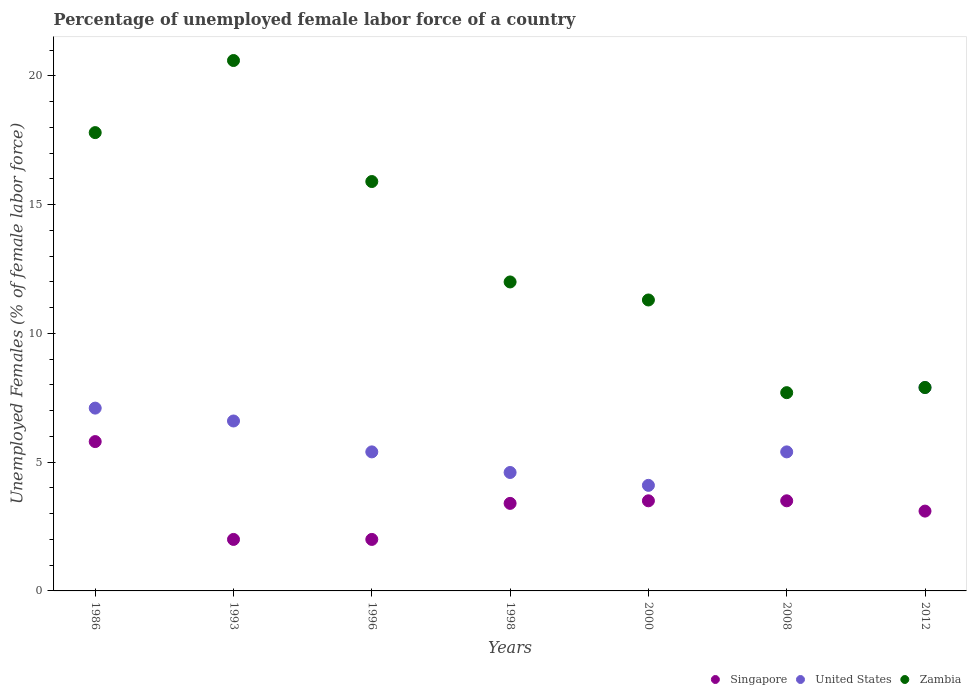How many different coloured dotlines are there?
Offer a very short reply. 3. What is the percentage of unemployed female labor force in Singapore in 1996?
Offer a terse response. 2. Across all years, what is the maximum percentage of unemployed female labor force in Singapore?
Ensure brevity in your answer.  5.8. Across all years, what is the minimum percentage of unemployed female labor force in Singapore?
Offer a terse response. 2. In which year was the percentage of unemployed female labor force in Zambia maximum?
Give a very brief answer. 1993. What is the total percentage of unemployed female labor force in Zambia in the graph?
Your response must be concise. 93.2. What is the difference between the percentage of unemployed female labor force in United States in 2000 and that in 2008?
Provide a succinct answer. -1.3. What is the difference between the percentage of unemployed female labor force in United States in 1993 and the percentage of unemployed female labor force in Singapore in 1986?
Your answer should be very brief. 0.8. What is the average percentage of unemployed female labor force in Zambia per year?
Your answer should be very brief. 13.31. In the year 1998, what is the difference between the percentage of unemployed female labor force in Singapore and percentage of unemployed female labor force in United States?
Provide a succinct answer. -1.2. What is the ratio of the percentage of unemployed female labor force in United States in 2008 to that in 2012?
Offer a terse response. 0.68. Is the percentage of unemployed female labor force in United States in 1986 less than that in 1993?
Your answer should be compact. No. What is the difference between the highest and the second highest percentage of unemployed female labor force in Zambia?
Your answer should be very brief. 2.8. What is the difference between the highest and the lowest percentage of unemployed female labor force in United States?
Keep it short and to the point. 3.8. Is the sum of the percentage of unemployed female labor force in Zambia in 1993 and 2008 greater than the maximum percentage of unemployed female labor force in United States across all years?
Your answer should be very brief. Yes. Is it the case that in every year, the sum of the percentage of unemployed female labor force in United States and percentage of unemployed female labor force in Zambia  is greater than the percentage of unemployed female labor force in Singapore?
Make the answer very short. Yes. Is the percentage of unemployed female labor force in United States strictly greater than the percentage of unemployed female labor force in Singapore over the years?
Provide a short and direct response. Yes. Is the percentage of unemployed female labor force in Singapore strictly less than the percentage of unemployed female labor force in Zambia over the years?
Offer a terse response. Yes. How many years are there in the graph?
Ensure brevity in your answer.  7. Are the values on the major ticks of Y-axis written in scientific E-notation?
Provide a short and direct response. No. How are the legend labels stacked?
Ensure brevity in your answer.  Horizontal. What is the title of the graph?
Your response must be concise. Percentage of unemployed female labor force of a country. What is the label or title of the X-axis?
Provide a succinct answer. Years. What is the label or title of the Y-axis?
Make the answer very short. Unemployed Females (% of female labor force). What is the Unemployed Females (% of female labor force) of Singapore in 1986?
Your response must be concise. 5.8. What is the Unemployed Females (% of female labor force) in United States in 1986?
Ensure brevity in your answer.  7.1. What is the Unemployed Females (% of female labor force) of Zambia in 1986?
Make the answer very short. 17.8. What is the Unemployed Females (% of female labor force) in United States in 1993?
Ensure brevity in your answer.  6.6. What is the Unemployed Females (% of female labor force) in Zambia in 1993?
Give a very brief answer. 20.6. What is the Unemployed Females (% of female labor force) of Singapore in 1996?
Make the answer very short. 2. What is the Unemployed Females (% of female labor force) in United States in 1996?
Give a very brief answer. 5.4. What is the Unemployed Females (% of female labor force) in Zambia in 1996?
Offer a terse response. 15.9. What is the Unemployed Females (% of female labor force) of Singapore in 1998?
Provide a succinct answer. 3.4. What is the Unemployed Females (% of female labor force) of United States in 1998?
Make the answer very short. 4.6. What is the Unemployed Females (% of female labor force) of Zambia in 1998?
Your answer should be compact. 12. What is the Unemployed Females (% of female labor force) in United States in 2000?
Keep it short and to the point. 4.1. What is the Unemployed Females (% of female labor force) of Zambia in 2000?
Offer a very short reply. 11.3. What is the Unemployed Females (% of female labor force) of Singapore in 2008?
Your answer should be very brief. 3.5. What is the Unemployed Females (% of female labor force) in United States in 2008?
Offer a very short reply. 5.4. What is the Unemployed Females (% of female labor force) of Zambia in 2008?
Offer a terse response. 7.7. What is the Unemployed Females (% of female labor force) of Singapore in 2012?
Provide a succinct answer. 3.1. What is the Unemployed Females (% of female labor force) of United States in 2012?
Offer a terse response. 7.9. What is the Unemployed Females (% of female labor force) in Zambia in 2012?
Give a very brief answer. 7.9. Across all years, what is the maximum Unemployed Females (% of female labor force) in Singapore?
Your answer should be very brief. 5.8. Across all years, what is the maximum Unemployed Females (% of female labor force) in United States?
Your response must be concise. 7.9. Across all years, what is the maximum Unemployed Females (% of female labor force) in Zambia?
Your response must be concise. 20.6. Across all years, what is the minimum Unemployed Females (% of female labor force) in Singapore?
Ensure brevity in your answer.  2. Across all years, what is the minimum Unemployed Females (% of female labor force) of United States?
Your response must be concise. 4.1. Across all years, what is the minimum Unemployed Females (% of female labor force) in Zambia?
Your answer should be very brief. 7.7. What is the total Unemployed Females (% of female labor force) of Singapore in the graph?
Offer a terse response. 23.3. What is the total Unemployed Females (% of female labor force) of United States in the graph?
Your answer should be very brief. 41.1. What is the total Unemployed Females (% of female labor force) in Zambia in the graph?
Ensure brevity in your answer.  93.2. What is the difference between the Unemployed Females (% of female labor force) in Singapore in 1986 and that in 1993?
Provide a short and direct response. 3.8. What is the difference between the Unemployed Females (% of female labor force) in Zambia in 1986 and that in 1993?
Provide a succinct answer. -2.8. What is the difference between the Unemployed Females (% of female labor force) of United States in 1986 and that in 1998?
Your answer should be compact. 2.5. What is the difference between the Unemployed Females (% of female labor force) of Zambia in 1986 and that in 1998?
Offer a terse response. 5.8. What is the difference between the Unemployed Females (% of female labor force) in Singapore in 1986 and that in 2000?
Offer a very short reply. 2.3. What is the difference between the Unemployed Females (% of female labor force) of United States in 1986 and that in 2000?
Offer a terse response. 3. What is the difference between the Unemployed Females (% of female labor force) in Zambia in 1986 and that in 2008?
Offer a very short reply. 10.1. What is the difference between the Unemployed Females (% of female labor force) of Singapore in 1986 and that in 2012?
Your response must be concise. 2.7. What is the difference between the Unemployed Females (% of female labor force) of Zambia in 1993 and that in 1996?
Provide a short and direct response. 4.7. What is the difference between the Unemployed Females (% of female labor force) in Singapore in 1993 and that in 2000?
Ensure brevity in your answer.  -1.5. What is the difference between the Unemployed Females (% of female labor force) in United States in 1993 and that in 2000?
Your answer should be compact. 2.5. What is the difference between the Unemployed Females (% of female labor force) of Singapore in 1993 and that in 2008?
Offer a very short reply. -1.5. What is the difference between the Unemployed Females (% of female labor force) of United States in 1993 and that in 2008?
Make the answer very short. 1.2. What is the difference between the Unemployed Females (% of female labor force) in United States in 1993 and that in 2012?
Your response must be concise. -1.3. What is the difference between the Unemployed Females (% of female labor force) of Zambia in 1993 and that in 2012?
Make the answer very short. 12.7. What is the difference between the Unemployed Females (% of female labor force) of Singapore in 1996 and that in 2000?
Offer a very short reply. -1.5. What is the difference between the Unemployed Females (% of female labor force) in United States in 1996 and that in 2000?
Make the answer very short. 1.3. What is the difference between the Unemployed Females (% of female labor force) in Singapore in 1996 and that in 2008?
Offer a very short reply. -1.5. What is the difference between the Unemployed Females (% of female labor force) of United States in 1996 and that in 2008?
Your answer should be compact. 0. What is the difference between the Unemployed Females (% of female labor force) of Zambia in 1996 and that in 2008?
Provide a short and direct response. 8.2. What is the difference between the Unemployed Females (% of female labor force) of United States in 1996 and that in 2012?
Provide a short and direct response. -2.5. What is the difference between the Unemployed Females (% of female labor force) in United States in 1998 and that in 2000?
Offer a terse response. 0.5. What is the difference between the Unemployed Females (% of female labor force) in Zambia in 1998 and that in 2008?
Give a very brief answer. 4.3. What is the difference between the Unemployed Females (% of female labor force) in United States in 1998 and that in 2012?
Make the answer very short. -3.3. What is the difference between the Unemployed Females (% of female labor force) of Zambia in 1998 and that in 2012?
Provide a short and direct response. 4.1. What is the difference between the Unemployed Females (% of female labor force) of Singapore in 2000 and that in 2008?
Keep it short and to the point. 0. What is the difference between the Unemployed Females (% of female labor force) of Singapore in 2000 and that in 2012?
Your response must be concise. 0.4. What is the difference between the Unemployed Females (% of female labor force) in United States in 2000 and that in 2012?
Keep it short and to the point. -3.8. What is the difference between the Unemployed Females (% of female labor force) in United States in 2008 and that in 2012?
Keep it short and to the point. -2.5. What is the difference between the Unemployed Females (% of female labor force) of Zambia in 2008 and that in 2012?
Make the answer very short. -0.2. What is the difference between the Unemployed Females (% of female labor force) of Singapore in 1986 and the Unemployed Females (% of female labor force) of United States in 1993?
Your response must be concise. -0.8. What is the difference between the Unemployed Females (% of female labor force) of Singapore in 1986 and the Unemployed Females (% of female labor force) of Zambia in 1993?
Make the answer very short. -14.8. What is the difference between the Unemployed Females (% of female labor force) of Singapore in 1986 and the Unemployed Females (% of female labor force) of Zambia in 1996?
Your response must be concise. -10.1. What is the difference between the Unemployed Females (% of female labor force) in United States in 1986 and the Unemployed Females (% of female labor force) in Zambia in 1996?
Provide a short and direct response. -8.8. What is the difference between the Unemployed Females (% of female labor force) of Singapore in 1986 and the Unemployed Females (% of female labor force) of United States in 1998?
Your answer should be very brief. 1.2. What is the difference between the Unemployed Females (% of female labor force) in Singapore in 1986 and the Unemployed Females (% of female labor force) in United States in 2008?
Provide a succinct answer. 0.4. What is the difference between the Unemployed Females (% of female labor force) in Singapore in 1986 and the Unemployed Females (% of female labor force) in Zambia in 2008?
Your response must be concise. -1.9. What is the difference between the Unemployed Females (% of female labor force) in United States in 1986 and the Unemployed Females (% of female labor force) in Zambia in 2008?
Give a very brief answer. -0.6. What is the difference between the Unemployed Females (% of female labor force) in Singapore in 1986 and the Unemployed Females (% of female labor force) in Zambia in 2012?
Your answer should be very brief. -2.1. What is the difference between the Unemployed Females (% of female labor force) in United States in 1986 and the Unemployed Females (% of female labor force) in Zambia in 2012?
Make the answer very short. -0.8. What is the difference between the Unemployed Females (% of female labor force) of Singapore in 1993 and the Unemployed Females (% of female labor force) of United States in 1996?
Offer a terse response. -3.4. What is the difference between the Unemployed Females (% of female labor force) of Singapore in 1993 and the Unemployed Females (% of female labor force) of Zambia in 1996?
Your response must be concise. -13.9. What is the difference between the Unemployed Females (% of female labor force) in United States in 1993 and the Unemployed Females (% of female labor force) in Zambia in 1996?
Make the answer very short. -9.3. What is the difference between the Unemployed Females (% of female labor force) in United States in 1993 and the Unemployed Females (% of female labor force) in Zambia in 1998?
Offer a very short reply. -5.4. What is the difference between the Unemployed Females (% of female labor force) in Singapore in 1993 and the Unemployed Females (% of female labor force) in United States in 2008?
Provide a short and direct response. -3.4. What is the difference between the Unemployed Females (% of female labor force) in Singapore in 1993 and the Unemployed Females (% of female labor force) in Zambia in 2008?
Keep it short and to the point. -5.7. What is the difference between the Unemployed Females (% of female labor force) in Singapore in 1993 and the Unemployed Females (% of female labor force) in Zambia in 2012?
Make the answer very short. -5.9. What is the difference between the Unemployed Females (% of female labor force) in Singapore in 1996 and the Unemployed Females (% of female labor force) in United States in 1998?
Offer a terse response. -2.6. What is the difference between the Unemployed Females (% of female labor force) of United States in 1996 and the Unemployed Females (% of female labor force) of Zambia in 1998?
Offer a terse response. -6.6. What is the difference between the Unemployed Females (% of female labor force) of Singapore in 1996 and the Unemployed Females (% of female labor force) of United States in 2000?
Ensure brevity in your answer.  -2.1. What is the difference between the Unemployed Females (% of female labor force) in United States in 1996 and the Unemployed Females (% of female labor force) in Zambia in 2008?
Keep it short and to the point. -2.3. What is the difference between the Unemployed Females (% of female labor force) in United States in 1996 and the Unemployed Females (% of female labor force) in Zambia in 2012?
Keep it short and to the point. -2.5. What is the difference between the Unemployed Females (% of female labor force) of Singapore in 1998 and the Unemployed Females (% of female labor force) of Zambia in 2000?
Ensure brevity in your answer.  -7.9. What is the difference between the Unemployed Females (% of female labor force) of United States in 1998 and the Unemployed Females (% of female labor force) of Zambia in 2008?
Give a very brief answer. -3.1. What is the difference between the Unemployed Females (% of female labor force) in Singapore in 1998 and the Unemployed Females (% of female labor force) in United States in 2012?
Provide a short and direct response. -4.5. What is the difference between the Unemployed Females (% of female labor force) of Singapore in 2000 and the Unemployed Females (% of female labor force) of United States in 2008?
Provide a succinct answer. -1.9. What is the difference between the Unemployed Females (% of female labor force) of Singapore in 2000 and the Unemployed Females (% of female labor force) of Zambia in 2008?
Your response must be concise. -4.2. What is the difference between the Unemployed Females (% of female labor force) of Singapore in 2000 and the Unemployed Females (% of female labor force) of United States in 2012?
Ensure brevity in your answer.  -4.4. What is the difference between the Unemployed Females (% of female labor force) in Singapore in 2000 and the Unemployed Females (% of female labor force) in Zambia in 2012?
Provide a short and direct response. -4.4. What is the average Unemployed Females (% of female labor force) in Singapore per year?
Offer a very short reply. 3.33. What is the average Unemployed Females (% of female labor force) of United States per year?
Provide a succinct answer. 5.87. What is the average Unemployed Females (% of female labor force) in Zambia per year?
Give a very brief answer. 13.31. In the year 1986, what is the difference between the Unemployed Females (% of female labor force) in Singapore and Unemployed Females (% of female labor force) in United States?
Your answer should be compact. -1.3. In the year 1986, what is the difference between the Unemployed Females (% of female labor force) of Singapore and Unemployed Females (% of female labor force) of Zambia?
Offer a terse response. -12. In the year 1993, what is the difference between the Unemployed Females (% of female labor force) of Singapore and Unemployed Females (% of female labor force) of United States?
Ensure brevity in your answer.  -4.6. In the year 1993, what is the difference between the Unemployed Females (% of female labor force) of Singapore and Unemployed Females (% of female labor force) of Zambia?
Offer a terse response. -18.6. In the year 1993, what is the difference between the Unemployed Females (% of female labor force) of United States and Unemployed Females (% of female labor force) of Zambia?
Make the answer very short. -14. In the year 1996, what is the difference between the Unemployed Females (% of female labor force) in Singapore and Unemployed Females (% of female labor force) in United States?
Your response must be concise. -3.4. In the year 1996, what is the difference between the Unemployed Females (% of female labor force) in Singapore and Unemployed Females (% of female labor force) in Zambia?
Offer a terse response. -13.9. In the year 1996, what is the difference between the Unemployed Females (% of female labor force) in United States and Unemployed Females (% of female labor force) in Zambia?
Your answer should be compact. -10.5. In the year 1998, what is the difference between the Unemployed Females (% of female labor force) of Singapore and Unemployed Females (% of female labor force) of Zambia?
Your response must be concise. -8.6. In the year 2000, what is the difference between the Unemployed Females (% of female labor force) in Singapore and Unemployed Females (% of female labor force) in United States?
Your response must be concise. -0.6. In the year 2008, what is the difference between the Unemployed Females (% of female labor force) of Singapore and Unemployed Females (% of female labor force) of United States?
Offer a very short reply. -1.9. In the year 2012, what is the difference between the Unemployed Females (% of female labor force) of Singapore and Unemployed Females (% of female labor force) of United States?
Keep it short and to the point. -4.8. In the year 2012, what is the difference between the Unemployed Females (% of female labor force) in United States and Unemployed Females (% of female labor force) in Zambia?
Provide a succinct answer. 0. What is the ratio of the Unemployed Females (% of female labor force) in United States in 1986 to that in 1993?
Offer a very short reply. 1.08. What is the ratio of the Unemployed Females (% of female labor force) in Zambia in 1986 to that in 1993?
Ensure brevity in your answer.  0.86. What is the ratio of the Unemployed Females (% of female labor force) of United States in 1986 to that in 1996?
Provide a succinct answer. 1.31. What is the ratio of the Unemployed Females (% of female labor force) of Zambia in 1986 to that in 1996?
Offer a very short reply. 1.12. What is the ratio of the Unemployed Females (% of female labor force) in Singapore in 1986 to that in 1998?
Make the answer very short. 1.71. What is the ratio of the Unemployed Females (% of female labor force) in United States in 1986 to that in 1998?
Give a very brief answer. 1.54. What is the ratio of the Unemployed Females (% of female labor force) in Zambia in 1986 to that in 1998?
Your response must be concise. 1.48. What is the ratio of the Unemployed Females (% of female labor force) in Singapore in 1986 to that in 2000?
Provide a succinct answer. 1.66. What is the ratio of the Unemployed Females (% of female labor force) of United States in 1986 to that in 2000?
Your response must be concise. 1.73. What is the ratio of the Unemployed Females (% of female labor force) of Zambia in 1986 to that in 2000?
Your response must be concise. 1.58. What is the ratio of the Unemployed Females (% of female labor force) of Singapore in 1986 to that in 2008?
Offer a terse response. 1.66. What is the ratio of the Unemployed Females (% of female labor force) in United States in 1986 to that in 2008?
Your answer should be compact. 1.31. What is the ratio of the Unemployed Females (% of female labor force) of Zambia in 1986 to that in 2008?
Offer a terse response. 2.31. What is the ratio of the Unemployed Females (% of female labor force) of Singapore in 1986 to that in 2012?
Your response must be concise. 1.87. What is the ratio of the Unemployed Females (% of female labor force) in United States in 1986 to that in 2012?
Provide a short and direct response. 0.9. What is the ratio of the Unemployed Females (% of female labor force) of Zambia in 1986 to that in 2012?
Your answer should be very brief. 2.25. What is the ratio of the Unemployed Females (% of female labor force) of Singapore in 1993 to that in 1996?
Your answer should be compact. 1. What is the ratio of the Unemployed Females (% of female labor force) in United States in 1993 to that in 1996?
Ensure brevity in your answer.  1.22. What is the ratio of the Unemployed Females (% of female labor force) in Zambia in 1993 to that in 1996?
Keep it short and to the point. 1.3. What is the ratio of the Unemployed Females (% of female labor force) in Singapore in 1993 to that in 1998?
Provide a succinct answer. 0.59. What is the ratio of the Unemployed Females (% of female labor force) of United States in 1993 to that in 1998?
Your answer should be compact. 1.43. What is the ratio of the Unemployed Females (% of female labor force) of Zambia in 1993 to that in 1998?
Your response must be concise. 1.72. What is the ratio of the Unemployed Females (% of female labor force) in United States in 1993 to that in 2000?
Provide a succinct answer. 1.61. What is the ratio of the Unemployed Females (% of female labor force) in Zambia in 1993 to that in 2000?
Ensure brevity in your answer.  1.82. What is the ratio of the Unemployed Females (% of female labor force) of Singapore in 1993 to that in 2008?
Ensure brevity in your answer.  0.57. What is the ratio of the Unemployed Females (% of female labor force) of United States in 1993 to that in 2008?
Your response must be concise. 1.22. What is the ratio of the Unemployed Females (% of female labor force) in Zambia in 1993 to that in 2008?
Your answer should be compact. 2.68. What is the ratio of the Unemployed Females (% of female labor force) of Singapore in 1993 to that in 2012?
Your response must be concise. 0.65. What is the ratio of the Unemployed Females (% of female labor force) of United States in 1993 to that in 2012?
Provide a succinct answer. 0.84. What is the ratio of the Unemployed Females (% of female labor force) in Zambia in 1993 to that in 2012?
Your response must be concise. 2.61. What is the ratio of the Unemployed Females (% of female labor force) of Singapore in 1996 to that in 1998?
Offer a terse response. 0.59. What is the ratio of the Unemployed Females (% of female labor force) of United States in 1996 to that in 1998?
Provide a short and direct response. 1.17. What is the ratio of the Unemployed Females (% of female labor force) in Zambia in 1996 to that in 1998?
Your answer should be compact. 1.32. What is the ratio of the Unemployed Females (% of female labor force) in Singapore in 1996 to that in 2000?
Provide a short and direct response. 0.57. What is the ratio of the Unemployed Females (% of female labor force) of United States in 1996 to that in 2000?
Provide a succinct answer. 1.32. What is the ratio of the Unemployed Females (% of female labor force) in Zambia in 1996 to that in 2000?
Give a very brief answer. 1.41. What is the ratio of the Unemployed Females (% of female labor force) of Singapore in 1996 to that in 2008?
Your answer should be compact. 0.57. What is the ratio of the Unemployed Females (% of female labor force) of Zambia in 1996 to that in 2008?
Provide a succinct answer. 2.06. What is the ratio of the Unemployed Females (% of female labor force) of Singapore in 1996 to that in 2012?
Make the answer very short. 0.65. What is the ratio of the Unemployed Females (% of female labor force) of United States in 1996 to that in 2012?
Keep it short and to the point. 0.68. What is the ratio of the Unemployed Females (% of female labor force) in Zambia in 1996 to that in 2012?
Give a very brief answer. 2.01. What is the ratio of the Unemployed Females (% of female labor force) of Singapore in 1998 to that in 2000?
Offer a terse response. 0.97. What is the ratio of the Unemployed Females (% of female labor force) of United States in 1998 to that in 2000?
Offer a terse response. 1.12. What is the ratio of the Unemployed Females (% of female labor force) of Zambia in 1998 to that in 2000?
Give a very brief answer. 1.06. What is the ratio of the Unemployed Females (% of female labor force) of Singapore in 1998 to that in 2008?
Your answer should be very brief. 0.97. What is the ratio of the Unemployed Females (% of female labor force) of United States in 1998 to that in 2008?
Provide a succinct answer. 0.85. What is the ratio of the Unemployed Females (% of female labor force) of Zambia in 1998 to that in 2008?
Make the answer very short. 1.56. What is the ratio of the Unemployed Females (% of female labor force) in Singapore in 1998 to that in 2012?
Your answer should be very brief. 1.1. What is the ratio of the Unemployed Females (% of female labor force) in United States in 1998 to that in 2012?
Offer a very short reply. 0.58. What is the ratio of the Unemployed Females (% of female labor force) in Zambia in 1998 to that in 2012?
Provide a succinct answer. 1.52. What is the ratio of the Unemployed Females (% of female labor force) of Singapore in 2000 to that in 2008?
Your answer should be compact. 1. What is the ratio of the Unemployed Females (% of female labor force) of United States in 2000 to that in 2008?
Make the answer very short. 0.76. What is the ratio of the Unemployed Females (% of female labor force) of Zambia in 2000 to that in 2008?
Offer a very short reply. 1.47. What is the ratio of the Unemployed Females (% of female labor force) of Singapore in 2000 to that in 2012?
Your answer should be very brief. 1.13. What is the ratio of the Unemployed Females (% of female labor force) of United States in 2000 to that in 2012?
Keep it short and to the point. 0.52. What is the ratio of the Unemployed Females (% of female labor force) in Zambia in 2000 to that in 2012?
Your answer should be very brief. 1.43. What is the ratio of the Unemployed Females (% of female labor force) of Singapore in 2008 to that in 2012?
Keep it short and to the point. 1.13. What is the ratio of the Unemployed Females (% of female labor force) of United States in 2008 to that in 2012?
Your answer should be compact. 0.68. What is the ratio of the Unemployed Females (% of female labor force) in Zambia in 2008 to that in 2012?
Make the answer very short. 0.97. What is the difference between the highest and the second highest Unemployed Females (% of female labor force) in United States?
Your answer should be compact. 0.8. What is the difference between the highest and the lowest Unemployed Females (% of female labor force) of Singapore?
Your answer should be very brief. 3.8. 